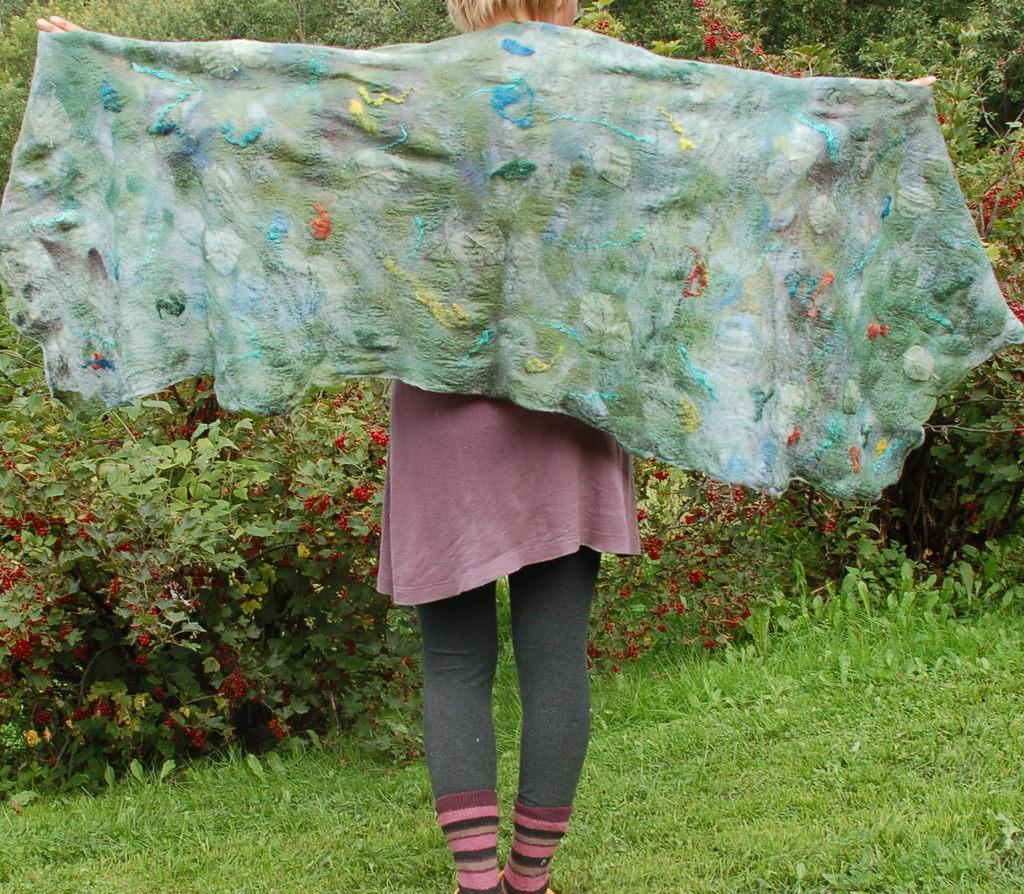Can you describe this image briefly? In this image we can see a person is standing and wearing pink color dress. Hand holding green color scarf. The land is covered with grass. Background of the image plants and trees are there. 